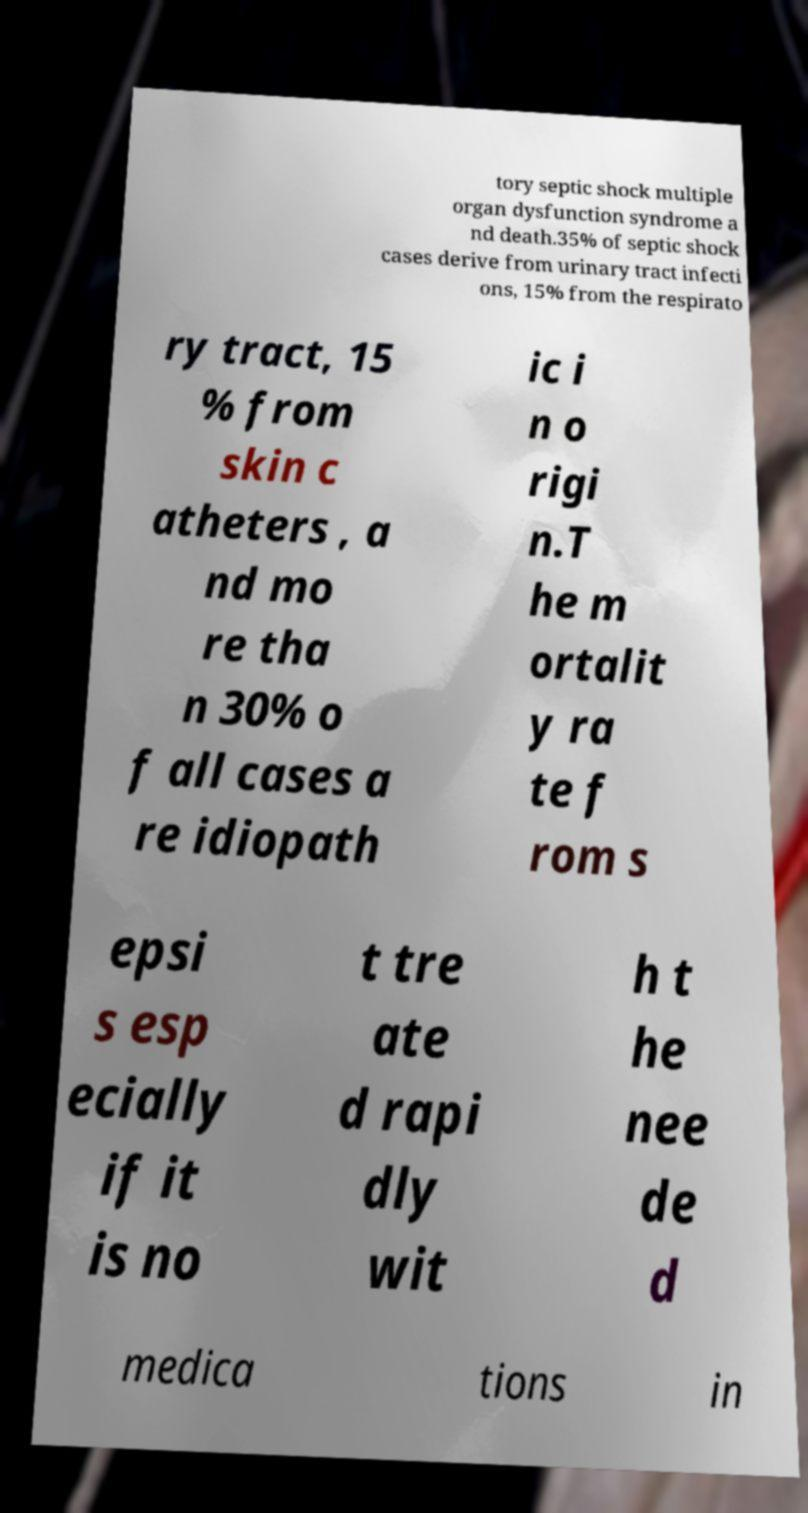There's text embedded in this image that I need extracted. Can you transcribe it verbatim? tory septic shock multiple organ dysfunction syndrome a nd death.35% of septic shock cases derive from urinary tract infecti ons, 15% from the respirato ry tract, 15 % from skin c atheters , a nd mo re tha n 30% o f all cases a re idiopath ic i n o rigi n.T he m ortalit y ra te f rom s epsi s esp ecially if it is no t tre ate d rapi dly wit h t he nee de d medica tions in 